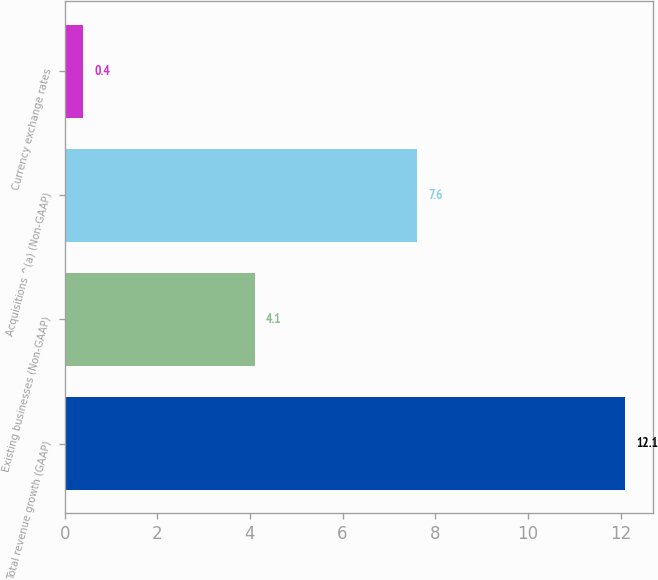Convert chart to OTSL. <chart><loc_0><loc_0><loc_500><loc_500><bar_chart><fcel>Total revenue growth (GAAP)<fcel>Existing businesses (Non-GAAP)<fcel>Acquisitions ^(a) (Non-GAAP)<fcel>Currency exchange rates<nl><fcel>12.1<fcel>4.1<fcel>7.6<fcel>0.4<nl></chart> 